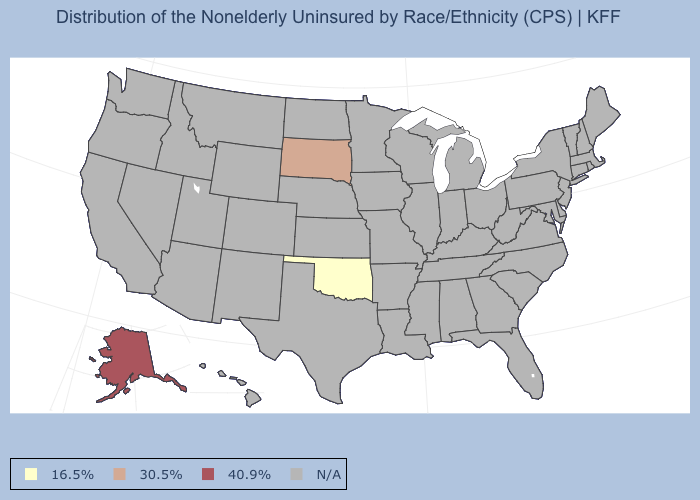What is the lowest value in the West?
Answer briefly. 40.9%. Which states have the lowest value in the USA?
Give a very brief answer. Oklahoma. What is the value of Hawaii?
Concise answer only. N/A. What is the value of North Dakota?
Give a very brief answer. N/A. Is the legend a continuous bar?
Give a very brief answer. No. Name the states that have a value in the range 40.9%?
Concise answer only. Alaska. What is the value of Connecticut?
Short answer required. N/A. Does the first symbol in the legend represent the smallest category?
Keep it brief. Yes. Which states have the lowest value in the South?
Write a very short answer. Oklahoma. 